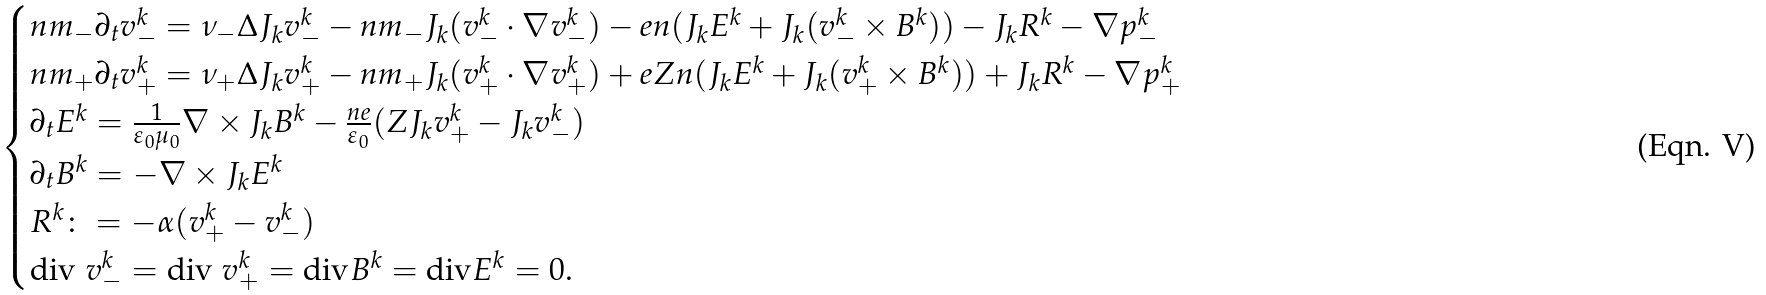<formula> <loc_0><loc_0><loc_500><loc_500>\begin{cases} n m _ { - } \partial _ { t } v _ { - } ^ { k } = \nu _ { - } \Delta J _ { k } v _ { - } ^ { k } - n m _ { - } J _ { k } ( v _ { - } ^ { k } \cdot \nabla v _ { - } ^ { k } ) - e n ( J _ { k } E ^ { k } + J _ { k } ( v _ { - } ^ { k } \times B ^ { k } ) ) - J _ { k } R ^ { k } - \nabla p _ { - } ^ { k } \\ n m _ { + } \partial _ { t } v _ { + } ^ { k } = \nu _ { + } \Delta J _ { k } v _ { + } ^ { k } - n m _ { + } J _ { k } ( v _ { + } ^ { k } \cdot \nabla v _ { + } ^ { k } ) + e Z n ( J _ { k } E ^ { k } + J _ { k } ( v _ { + } ^ { k } \times B ^ { k } ) ) + J _ { k } R ^ { k } - \nabla p _ { + } ^ { k } \\ \partial _ { t } E ^ { k } = \frac { 1 } { \varepsilon _ { 0 } \mu _ { 0 } } \nabla \times J _ { k } B ^ { k } - \frac { n e } { \varepsilon _ { 0 } } ( Z J _ { k } v _ { + } ^ { k } - J _ { k } v _ { - } ^ { k } ) \\ \partial _ { t } B ^ { k } = - \nabla \times J _ { k } E ^ { k } \\ R ^ { k } \colon = - \alpha ( v _ { + } ^ { k } - v _ { - } ^ { k } ) \\ \text {div } v _ { - } ^ { k } = \text {div } v _ { + } ^ { k } = \text {div} B ^ { k } = \text {div} E ^ { k } = 0 . \\ \end{cases}</formula> 